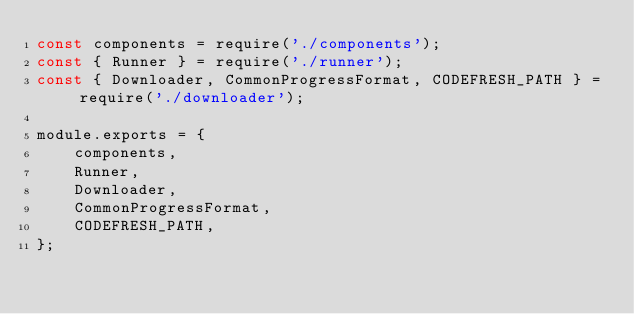<code> <loc_0><loc_0><loc_500><loc_500><_JavaScript_>const components = require('./components');
const { Runner } = require('./runner');
const { Downloader, CommonProgressFormat, CODEFRESH_PATH } = require('./downloader');

module.exports = {
    components,
    Runner,
    Downloader,
    CommonProgressFormat,
    CODEFRESH_PATH,
};
</code> 